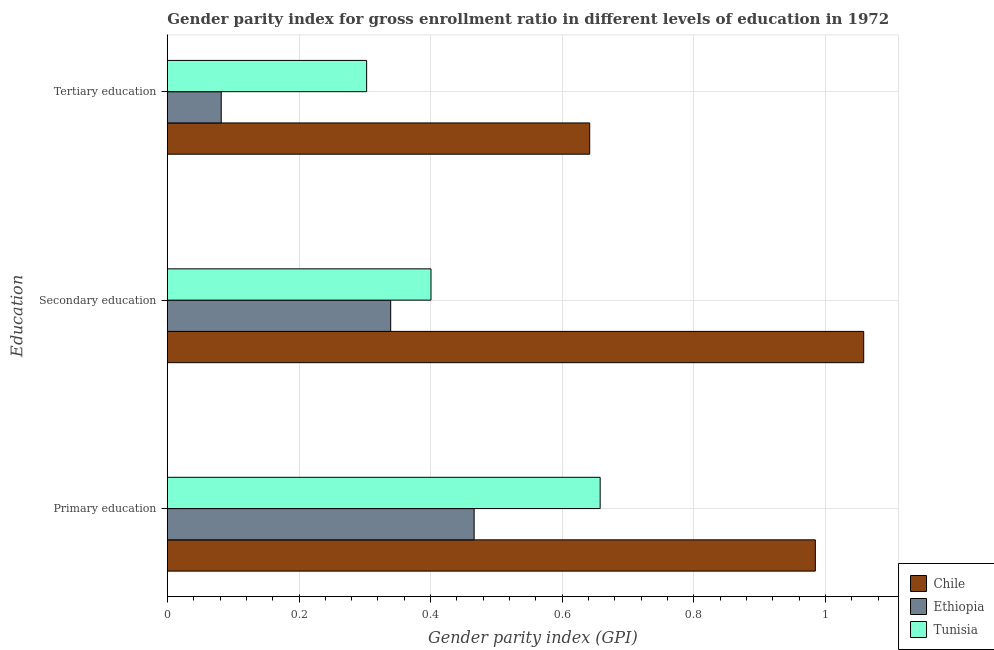How many different coloured bars are there?
Provide a succinct answer. 3. How many groups of bars are there?
Offer a terse response. 3. Are the number of bars per tick equal to the number of legend labels?
Ensure brevity in your answer.  Yes. How many bars are there on the 1st tick from the bottom?
Make the answer very short. 3. What is the gender parity index in tertiary education in Tunisia?
Your answer should be compact. 0.3. Across all countries, what is the maximum gender parity index in primary education?
Your response must be concise. 0.98. Across all countries, what is the minimum gender parity index in secondary education?
Your response must be concise. 0.34. In which country was the gender parity index in secondary education minimum?
Provide a short and direct response. Ethiopia. What is the total gender parity index in tertiary education in the graph?
Make the answer very short. 1.03. What is the difference between the gender parity index in tertiary education in Chile and that in Ethiopia?
Keep it short and to the point. 0.56. What is the difference between the gender parity index in tertiary education in Ethiopia and the gender parity index in secondary education in Chile?
Ensure brevity in your answer.  -0.98. What is the average gender parity index in secondary education per country?
Make the answer very short. 0.6. What is the difference between the gender parity index in tertiary education and gender parity index in secondary education in Ethiopia?
Make the answer very short. -0.26. What is the ratio of the gender parity index in tertiary education in Tunisia to that in Ethiopia?
Keep it short and to the point. 3.7. Is the gender parity index in secondary education in Ethiopia less than that in Chile?
Your answer should be compact. Yes. Is the difference between the gender parity index in secondary education in Ethiopia and Chile greater than the difference between the gender parity index in tertiary education in Ethiopia and Chile?
Keep it short and to the point. No. What is the difference between the highest and the second highest gender parity index in tertiary education?
Your answer should be compact. 0.34. What is the difference between the highest and the lowest gender parity index in primary education?
Offer a terse response. 0.52. What does the 1st bar from the top in Secondary education represents?
Provide a short and direct response. Tunisia. Are the values on the major ticks of X-axis written in scientific E-notation?
Provide a short and direct response. No. Does the graph contain grids?
Offer a very short reply. Yes. Where does the legend appear in the graph?
Your answer should be very brief. Bottom right. How are the legend labels stacked?
Offer a terse response. Vertical. What is the title of the graph?
Your answer should be compact. Gender parity index for gross enrollment ratio in different levels of education in 1972. Does "Lithuania" appear as one of the legend labels in the graph?
Give a very brief answer. No. What is the label or title of the X-axis?
Provide a short and direct response. Gender parity index (GPI). What is the label or title of the Y-axis?
Offer a terse response. Education. What is the Gender parity index (GPI) in Chile in Primary education?
Provide a succinct answer. 0.98. What is the Gender parity index (GPI) in Ethiopia in Primary education?
Your answer should be compact. 0.47. What is the Gender parity index (GPI) in Tunisia in Primary education?
Give a very brief answer. 0.66. What is the Gender parity index (GPI) in Chile in Secondary education?
Provide a succinct answer. 1.06. What is the Gender parity index (GPI) of Ethiopia in Secondary education?
Ensure brevity in your answer.  0.34. What is the Gender parity index (GPI) of Tunisia in Secondary education?
Make the answer very short. 0.4. What is the Gender parity index (GPI) in Chile in Tertiary education?
Give a very brief answer. 0.64. What is the Gender parity index (GPI) in Ethiopia in Tertiary education?
Provide a short and direct response. 0.08. What is the Gender parity index (GPI) in Tunisia in Tertiary education?
Offer a terse response. 0.3. Across all Education, what is the maximum Gender parity index (GPI) in Chile?
Give a very brief answer. 1.06. Across all Education, what is the maximum Gender parity index (GPI) in Ethiopia?
Give a very brief answer. 0.47. Across all Education, what is the maximum Gender parity index (GPI) of Tunisia?
Give a very brief answer. 0.66. Across all Education, what is the minimum Gender parity index (GPI) of Chile?
Make the answer very short. 0.64. Across all Education, what is the minimum Gender parity index (GPI) of Ethiopia?
Your answer should be very brief. 0.08. Across all Education, what is the minimum Gender parity index (GPI) of Tunisia?
Your response must be concise. 0.3. What is the total Gender parity index (GPI) of Chile in the graph?
Keep it short and to the point. 2.68. What is the total Gender parity index (GPI) in Ethiopia in the graph?
Make the answer very short. 0.89. What is the total Gender parity index (GPI) in Tunisia in the graph?
Keep it short and to the point. 1.36. What is the difference between the Gender parity index (GPI) in Chile in Primary education and that in Secondary education?
Keep it short and to the point. -0.07. What is the difference between the Gender parity index (GPI) of Ethiopia in Primary education and that in Secondary education?
Your response must be concise. 0.13. What is the difference between the Gender parity index (GPI) of Tunisia in Primary education and that in Secondary education?
Offer a terse response. 0.26. What is the difference between the Gender parity index (GPI) of Chile in Primary education and that in Tertiary education?
Your answer should be very brief. 0.34. What is the difference between the Gender parity index (GPI) of Ethiopia in Primary education and that in Tertiary education?
Provide a short and direct response. 0.38. What is the difference between the Gender parity index (GPI) of Tunisia in Primary education and that in Tertiary education?
Your answer should be very brief. 0.35. What is the difference between the Gender parity index (GPI) of Chile in Secondary education and that in Tertiary education?
Your answer should be very brief. 0.42. What is the difference between the Gender parity index (GPI) in Ethiopia in Secondary education and that in Tertiary education?
Offer a terse response. 0.26. What is the difference between the Gender parity index (GPI) in Tunisia in Secondary education and that in Tertiary education?
Ensure brevity in your answer.  0.1. What is the difference between the Gender parity index (GPI) in Chile in Primary education and the Gender parity index (GPI) in Ethiopia in Secondary education?
Offer a terse response. 0.65. What is the difference between the Gender parity index (GPI) of Chile in Primary education and the Gender parity index (GPI) of Tunisia in Secondary education?
Ensure brevity in your answer.  0.58. What is the difference between the Gender parity index (GPI) of Ethiopia in Primary education and the Gender parity index (GPI) of Tunisia in Secondary education?
Offer a terse response. 0.07. What is the difference between the Gender parity index (GPI) in Chile in Primary education and the Gender parity index (GPI) in Ethiopia in Tertiary education?
Provide a succinct answer. 0.9. What is the difference between the Gender parity index (GPI) of Chile in Primary education and the Gender parity index (GPI) of Tunisia in Tertiary education?
Keep it short and to the point. 0.68. What is the difference between the Gender parity index (GPI) in Ethiopia in Primary education and the Gender parity index (GPI) in Tunisia in Tertiary education?
Offer a very short reply. 0.16. What is the difference between the Gender parity index (GPI) of Chile in Secondary education and the Gender parity index (GPI) of Ethiopia in Tertiary education?
Your answer should be compact. 0.98. What is the difference between the Gender parity index (GPI) in Chile in Secondary education and the Gender parity index (GPI) in Tunisia in Tertiary education?
Provide a succinct answer. 0.76. What is the difference between the Gender parity index (GPI) in Ethiopia in Secondary education and the Gender parity index (GPI) in Tunisia in Tertiary education?
Ensure brevity in your answer.  0.04. What is the average Gender parity index (GPI) in Chile per Education?
Make the answer very short. 0.89. What is the average Gender parity index (GPI) in Ethiopia per Education?
Give a very brief answer. 0.3. What is the average Gender parity index (GPI) of Tunisia per Education?
Provide a succinct answer. 0.45. What is the difference between the Gender parity index (GPI) of Chile and Gender parity index (GPI) of Ethiopia in Primary education?
Ensure brevity in your answer.  0.52. What is the difference between the Gender parity index (GPI) of Chile and Gender parity index (GPI) of Tunisia in Primary education?
Make the answer very short. 0.33. What is the difference between the Gender parity index (GPI) of Ethiopia and Gender parity index (GPI) of Tunisia in Primary education?
Provide a short and direct response. -0.19. What is the difference between the Gender parity index (GPI) of Chile and Gender parity index (GPI) of Ethiopia in Secondary education?
Your response must be concise. 0.72. What is the difference between the Gender parity index (GPI) in Chile and Gender parity index (GPI) in Tunisia in Secondary education?
Your response must be concise. 0.66. What is the difference between the Gender parity index (GPI) of Ethiopia and Gender parity index (GPI) of Tunisia in Secondary education?
Your answer should be very brief. -0.06. What is the difference between the Gender parity index (GPI) in Chile and Gender parity index (GPI) in Ethiopia in Tertiary education?
Your answer should be very brief. 0.56. What is the difference between the Gender parity index (GPI) in Chile and Gender parity index (GPI) in Tunisia in Tertiary education?
Provide a succinct answer. 0.34. What is the difference between the Gender parity index (GPI) of Ethiopia and Gender parity index (GPI) of Tunisia in Tertiary education?
Give a very brief answer. -0.22. What is the ratio of the Gender parity index (GPI) in Chile in Primary education to that in Secondary education?
Keep it short and to the point. 0.93. What is the ratio of the Gender parity index (GPI) of Ethiopia in Primary education to that in Secondary education?
Your answer should be compact. 1.37. What is the ratio of the Gender parity index (GPI) of Tunisia in Primary education to that in Secondary education?
Offer a very short reply. 1.64. What is the ratio of the Gender parity index (GPI) of Chile in Primary education to that in Tertiary education?
Provide a succinct answer. 1.53. What is the ratio of the Gender parity index (GPI) of Ethiopia in Primary education to that in Tertiary education?
Ensure brevity in your answer.  5.7. What is the ratio of the Gender parity index (GPI) in Tunisia in Primary education to that in Tertiary education?
Make the answer very short. 2.17. What is the ratio of the Gender parity index (GPI) in Chile in Secondary education to that in Tertiary education?
Give a very brief answer. 1.65. What is the ratio of the Gender parity index (GPI) of Ethiopia in Secondary education to that in Tertiary education?
Offer a terse response. 4.15. What is the ratio of the Gender parity index (GPI) in Tunisia in Secondary education to that in Tertiary education?
Offer a very short reply. 1.32. What is the difference between the highest and the second highest Gender parity index (GPI) in Chile?
Provide a succinct answer. 0.07. What is the difference between the highest and the second highest Gender parity index (GPI) of Ethiopia?
Provide a succinct answer. 0.13. What is the difference between the highest and the second highest Gender parity index (GPI) of Tunisia?
Make the answer very short. 0.26. What is the difference between the highest and the lowest Gender parity index (GPI) in Chile?
Give a very brief answer. 0.42. What is the difference between the highest and the lowest Gender parity index (GPI) of Ethiopia?
Ensure brevity in your answer.  0.38. What is the difference between the highest and the lowest Gender parity index (GPI) in Tunisia?
Your answer should be very brief. 0.35. 